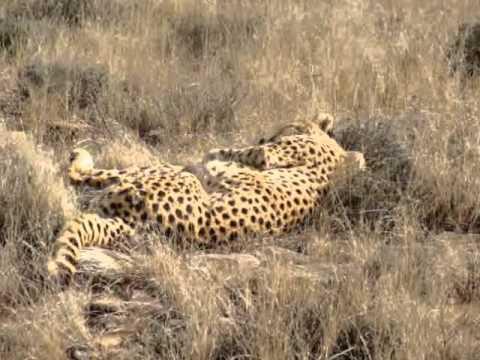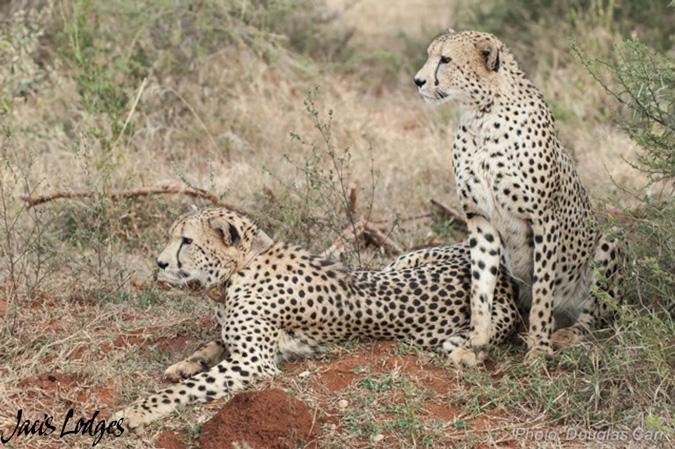The first image is the image on the left, the second image is the image on the right. For the images shown, is this caption "A lone cheetah can be seen chasing at least one zebra." true? Answer yes or no. No. The first image is the image on the left, the second image is the image on the right. Analyze the images presented: Is the assertion "One image shows a single cheetah behind at least one zebra and bounding rightward across the field towards the zebra." valid? Answer yes or no. No. 